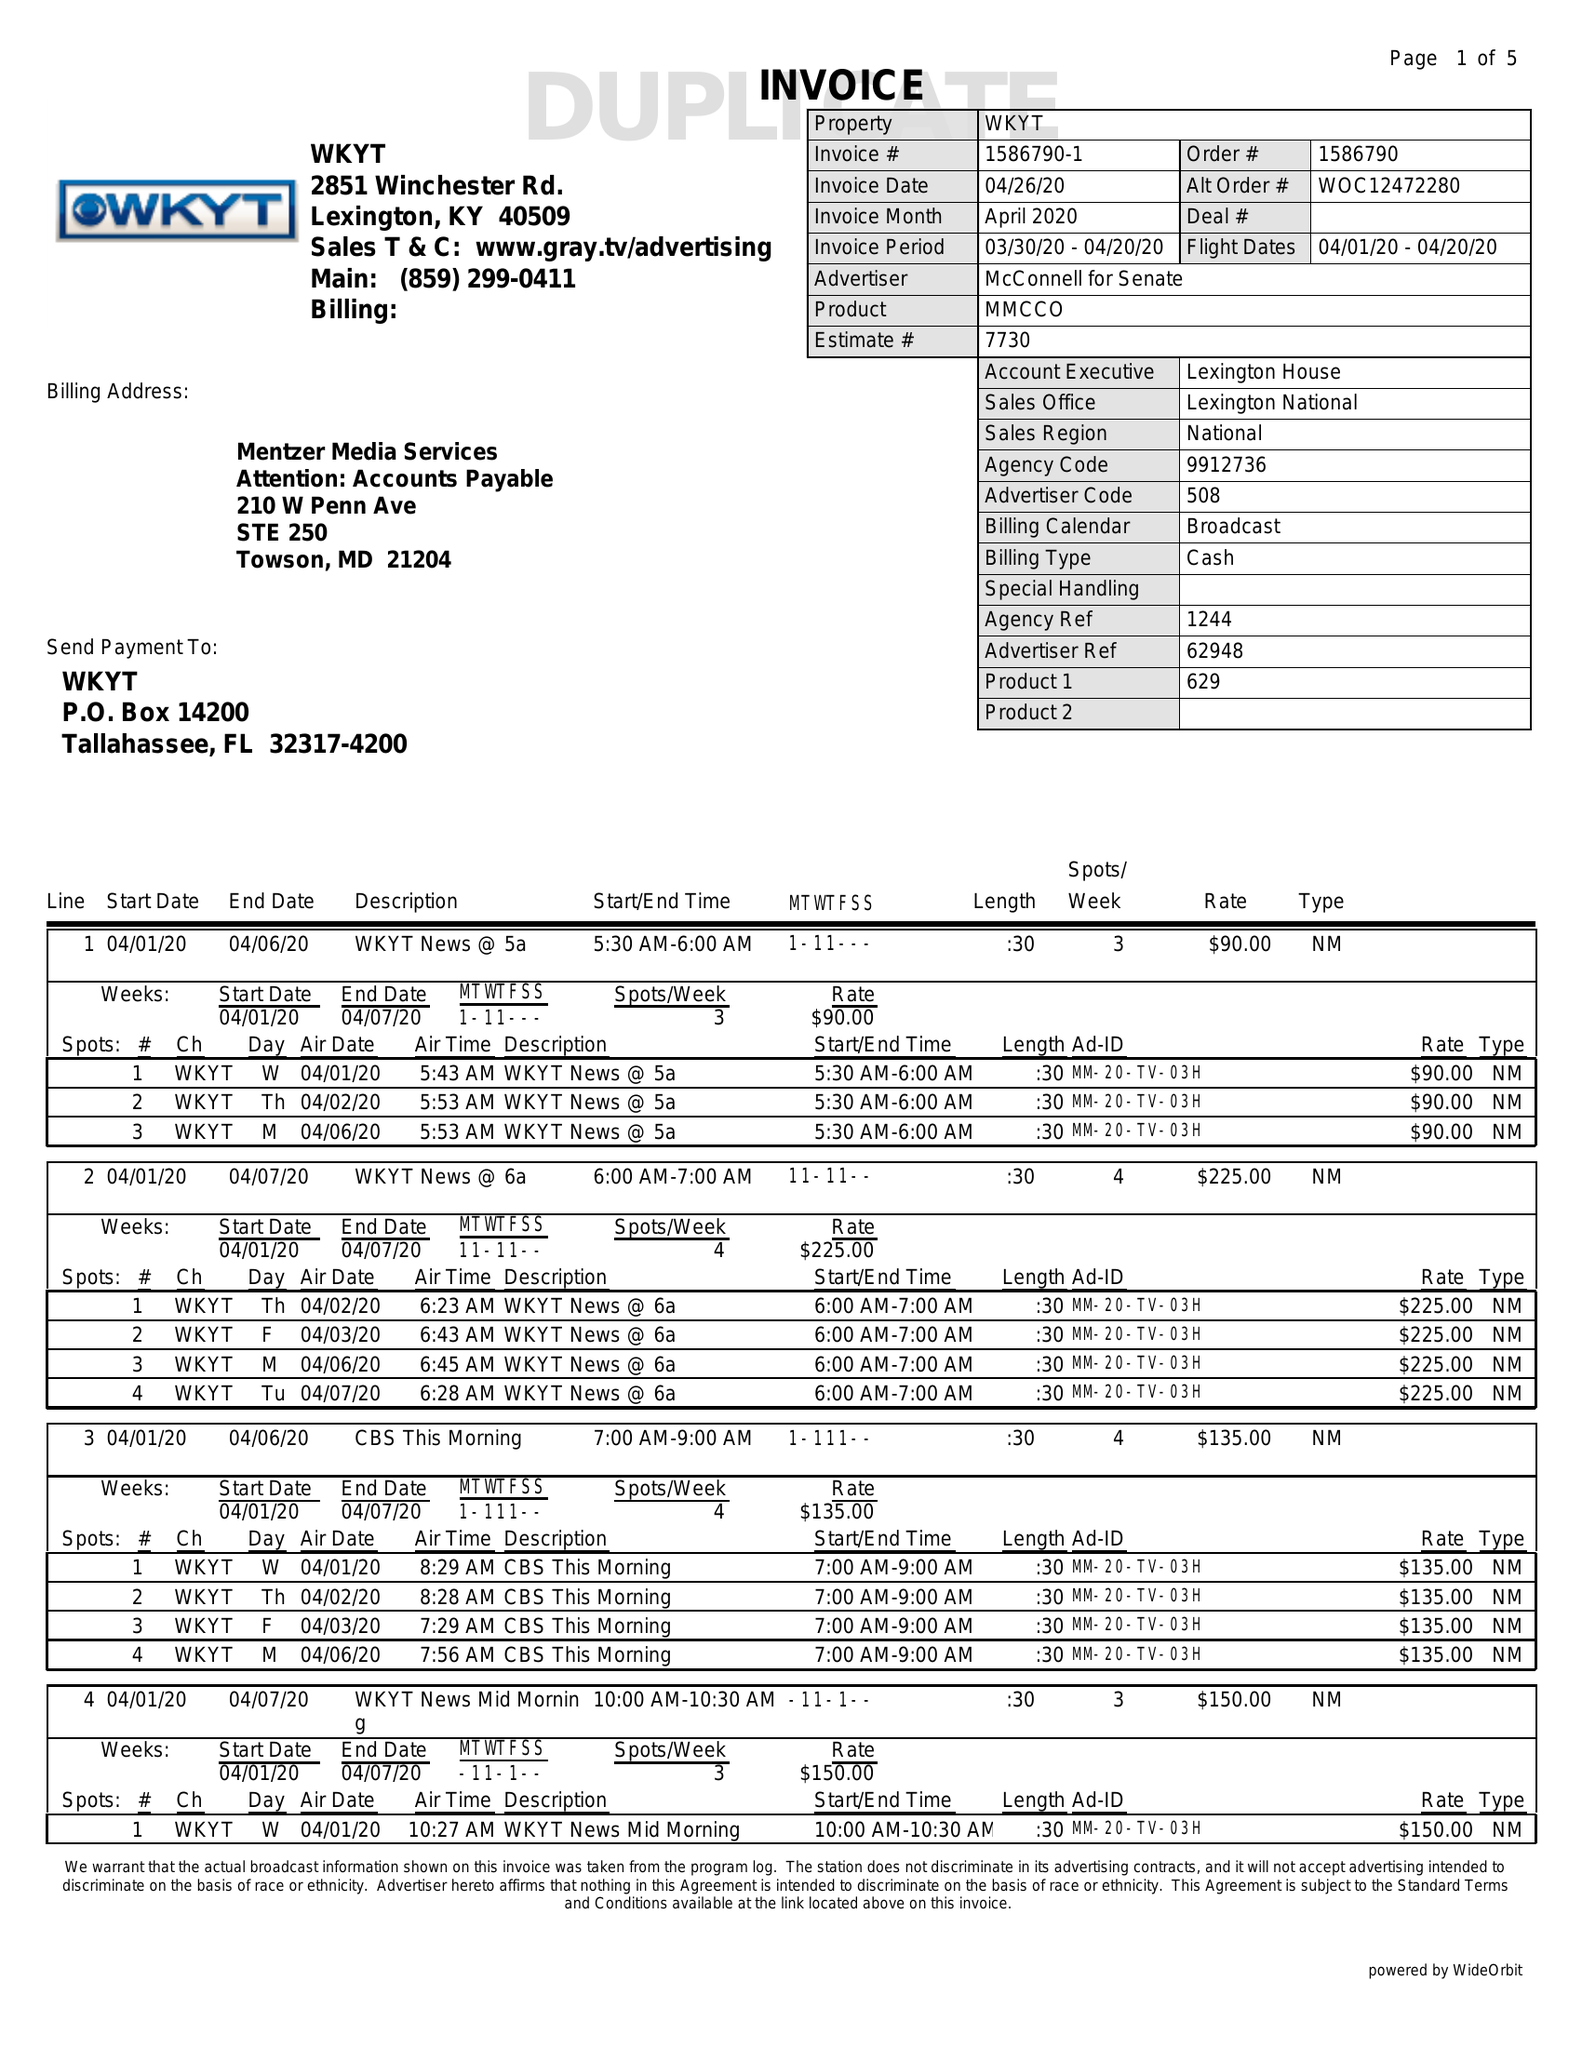What is the value for the flight_to?
Answer the question using a single word or phrase. 04/20/20 